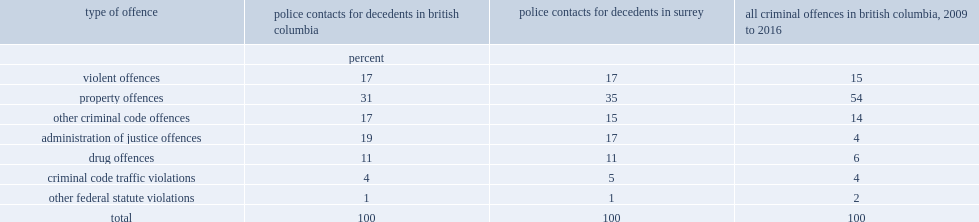Among all decedents in british coulumbia who came into contact with police prior to their fatal overdose, what is the percentage of those who did so for a non-violent crime? 83. Among all the types of offence, which type was the most common category of offence for which decedents had contact with police in the 24 months prior to their overdose both in british columbia and surrey? Property offences. 